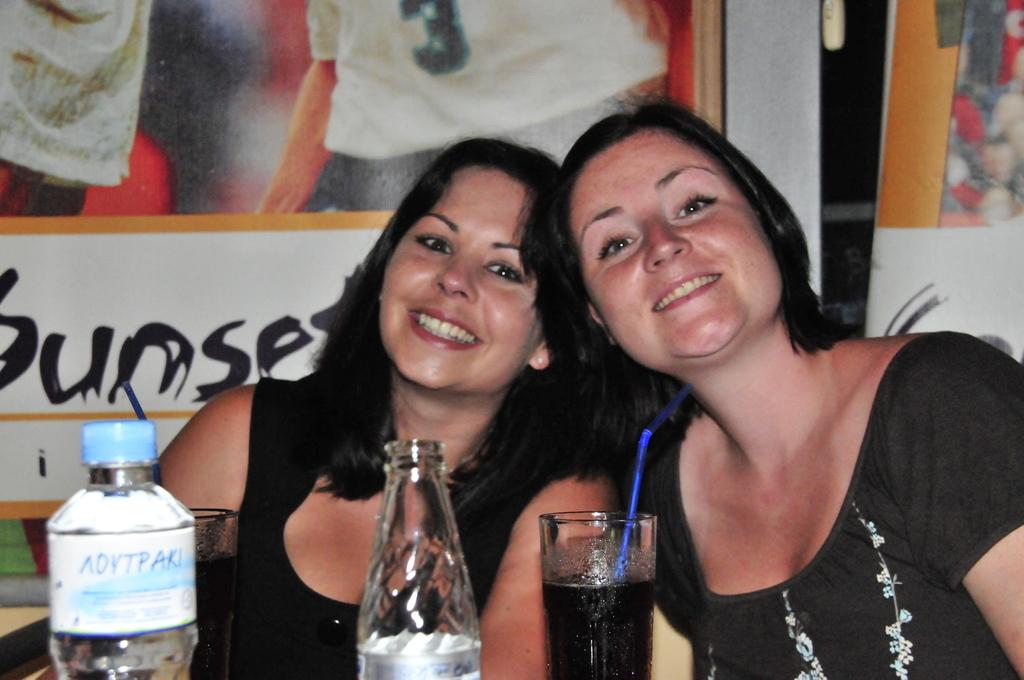How many women are in the image? There are two women in the image. What are the women wearing? The women are wearing black dresses. What objects are in front of the women? There is a water bottle and glasses in front of the women. What type of yam is being used as a prop in the image? There is no yam present in the image. What is the weather like in the image? The provided facts do not give any information about the weather in the image. 